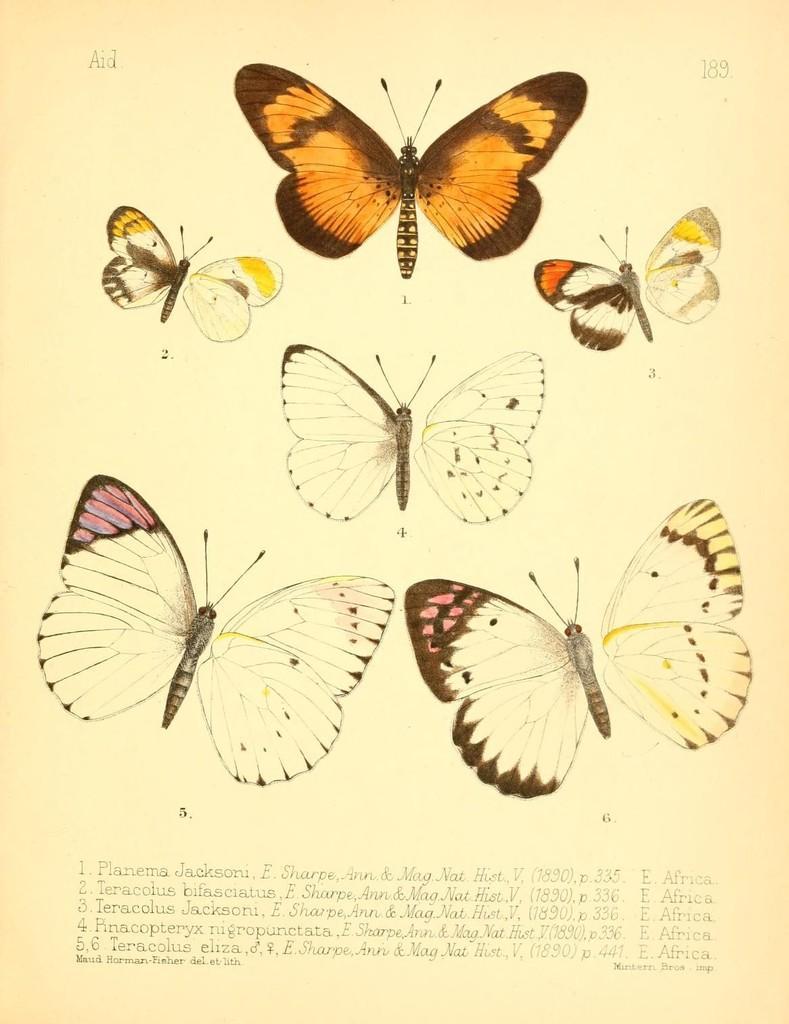Could you give a brief overview of what you see in this image? This image is a paper, on that paper there are pictures of a butterflies. 